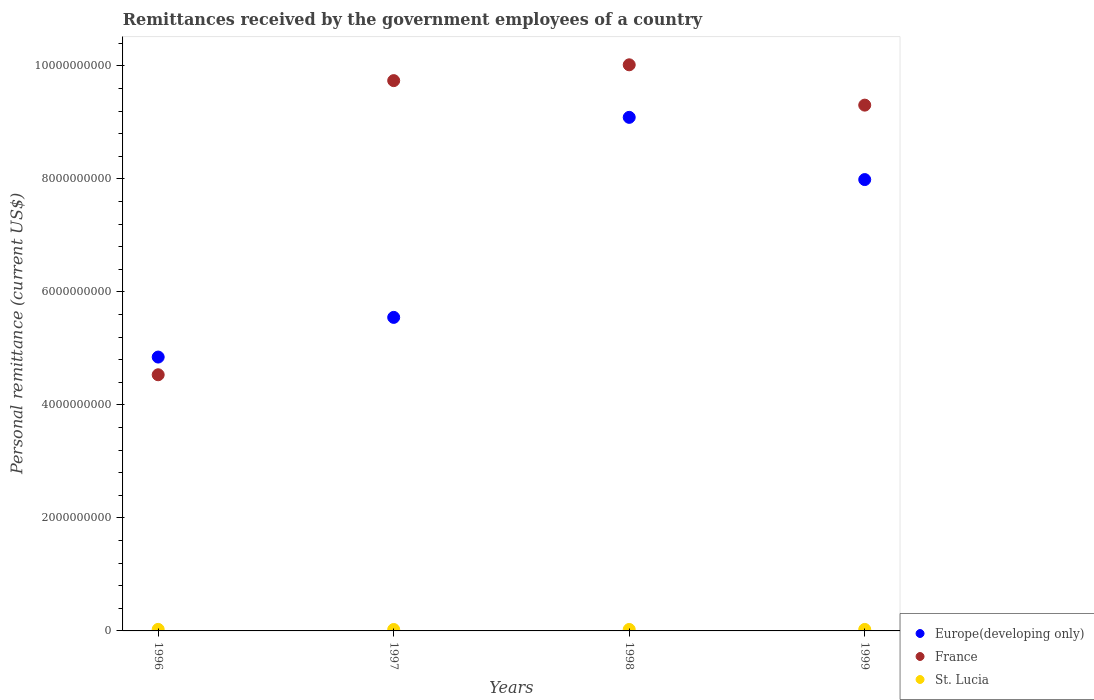What is the remittances received by the government employees in France in 1999?
Keep it short and to the point. 9.31e+09. Across all years, what is the maximum remittances received by the government employees in St. Lucia?
Keep it short and to the point. 2.74e+07. Across all years, what is the minimum remittances received by the government employees in St. Lucia?
Ensure brevity in your answer.  2.52e+07. In which year was the remittances received by the government employees in France minimum?
Ensure brevity in your answer.  1996. What is the total remittances received by the government employees in France in the graph?
Offer a terse response. 3.36e+1. What is the difference between the remittances received by the government employees in Europe(developing only) in 1998 and that in 1999?
Ensure brevity in your answer.  1.10e+09. What is the difference between the remittances received by the government employees in St. Lucia in 1997 and the remittances received by the government employees in Europe(developing only) in 1999?
Offer a very short reply. -7.96e+09. What is the average remittances received by the government employees in St. Lucia per year?
Ensure brevity in your answer.  2.63e+07. In the year 1996, what is the difference between the remittances received by the government employees in St. Lucia and remittances received by the government employees in France?
Ensure brevity in your answer.  -4.51e+09. What is the ratio of the remittances received by the government employees in Europe(developing only) in 1996 to that in 1999?
Your answer should be compact. 0.61. Is the remittances received by the government employees in Europe(developing only) in 1997 less than that in 1998?
Your response must be concise. Yes. Is the difference between the remittances received by the government employees in St. Lucia in 1997 and 1998 greater than the difference between the remittances received by the government employees in France in 1997 and 1998?
Offer a very short reply. Yes. What is the difference between the highest and the second highest remittances received by the government employees in Europe(developing only)?
Provide a succinct answer. 1.10e+09. What is the difference between the highest and the lowest remittances received by the government employees in St. Lucia?
Your response must be concise. 2.17e+06. Is it the case that in every year, the sum of the remittances received by the government employees in Europe(developing only) and remittances received by the government employees in France  is greater than the remittances received by the government employees in St. Lucia?
Ensure brevity in your answer.  Yes. Is the remittances received by the government employees in France strictly greater than the remittances received by the government employees in St. Lucia over the years?
Ensure brevity in your answer.  Yes. Is the remittances received by the government employees in St. Lucia strictly less than the remittances received by the government employees in France over the years?
Your answer should be very brief. Yes. How many dotlines are there?
Your answer should be very brief. 3. How many years are there in the graph?
Provide a succinct answer. 4. What is the difference between two consecutive major ticks on the Y-axis?
Keep it short and to the point. 2.00e+09. Does the graph contain any zero values?
Provide a succinct answer. No. Where does the legend appear in the graph?
Offer a very short reply. Bottom right. How many legend labels are there?
Give a very brief answer. 3. What is the title of the graph?
Give a very brief answer. Remittances received by the government employees of a country. What is the label or title of the Y-axis?
Provide a succinct answer. Personal remittance (current US$). What is the Personal remittance (current US$) in Europe(developing only) in 1996?
Keep it short and to the point. 4.85e+09. What is the Personal remittance (current US$) of France in 1996?
Give a very brief answer. 4.53e+09. What is the Personal remittance (current US$) of St. Lucia in 1996?
Offer a very short reply. 2.74e+07. What is the Personal remittance (current US$) in Europe(developing only) in 1997?
Provide a short and direct response. 5.55e+09. What is the Personal remittance (current US$) of France in 1997?
Keep it short and to the point. 9.74e+09. What is the Personal remittance (current US$) in St. Lucia in 1997?
Keep it short and to the point. 2.52e+07. What is the Personal remittance (current US$) in Europe(developing only) in 1998?
Provide a short and direct response. 9.09e+09. What is the Personal remittance (current US$) in France in 1998?
Your answer should be very brief. 1.00e+1. What is the Personal remittance (current US$) of St. Lucia in 1998?
Give a very brief answer. 2.59e+07. What is the Personal remittance (current US$) of Europe(developing only) in 1999?
Keep it short and to the point. 7.99e+09. What is the Personal remittance (current US$) of France in 1999?
Your response must be concise. 9.31e+09. What is the Personal remittance (current US$) in St. Lucia in 1999?
Offer a terse response. 2.65e+07. Across all years, what is the maximum Personal remittance (current US$) of Europe(developing only)?
Offer a very short reply. 9.09e+09. Across all years, what is the maximum Personal remittance (current US$) of France?
Your answer should be compact. 1.00e+1. Across all years, what is the maximum Personal remittance (current US$) of St. Lucia?
Offer a terse response. 2.74e+07. Across all years, what is the minimum Personal remittance (current US$) in Europe(developing only)?
Your answer should be very brief. 4.85e+09. Across all years, what is the minimum Personal remittance (current US$) of France?
Provide a short and direct response. 4.53e+09. Across all years, what is the minimum Personal remittance (current US$) in St. Lucia?
Provide a short and direct response. 2.52e+07. What is the total Personal remittance (current US$) in Europe(developing only) in the graph?
Your response must be concise. 2.75e+1. What is the total Personal remittance (current US$) in France in the graph?
Offer a terse response. 3.36e+1. What is the total Personal remittance (current US$) of St. Lucia in the graph?
Provide a succinct answer. 1.05e+08. What is the difference between the Personal remittance (current US$) in Europe(developing only) in 1996 and that in 1997?
Provide a succinct answer. -7.02e+08. What is the difference between the Personal remittance (current US$) of France in 1996 and that in 1997?
Your answer should be very brief. -5.21e+09. What is the difference between the Personal remittance (current US$) in St. Lucia in 1996 and that in 1997?
Make the answer very short. 2.17e+06. What is the difference between the Personal remittance (current US$) of Europe(developing only) in 1996 and that in 1998?
Provide a short and direct response. -4.24e+09. What is the difference between the Personal remittance (current US$) of France in 1996 and that in 1998?
Give a very brief answer. -5.49e+09. What is the difference between the Personal remittance (current US$) of St. Lucia in 1996 and that in 1998?
Provide a short and direct response. 1.47e+06. What is the difference between the Personal remittance (current US$) in Europe(developing only) in 1996 and that in 1999?
Provide a short and direct response. -3.14e+09. What is the difference between the Personal remittance (current US$) of France in 1996 and that in 1999?
Offer a terse response. -4.77e+09. What is the difference between the Personal remittance (current US$) in St. Lucia in 1996 and that in 1999?
Ensure brevity in your answer.  8.48e+05. What is the difference between the Personal remittance (current US$) in Europe(developing only) in 1997 and that in 1998?
Your response must be concise. -3.54e+09. What is the difference between the Personal remittance (current US$) in France in 1997 and that in 1998?
Keep it short and to the point. -2.80e+08. What is the difference between the Personal remittance (current US$) in St. Lucia in 1997 and that in 1998?
Keep it short and to the point. -7.00e+05. What is the difference between the Personal remittance (current US$) of Europe(developing only) in 1997 and that in 1999?
Make the answer very short. -2.44e+09. What is the difference between the Personal remittance (current US$) in France in 1997 and that in 1999?
Your response must be concise. 4.34e+08. What is the difference between the Personal remittance (current US$) of St. Lucia in 1997 and that in 1999?
Provide a short and direct response. -1.32e+06. What is the difference between the Personal remittance (current US$) of Europe(developing only) in 1998 and that in 1999?
Offer a very short reply. 1.10e+09. What is the difference between the Personal remittance (current US$) in France in 1998 and that in 1999?
Make the answer very short. 7.14e+08. What is the difference between the Personal remittance (current US$) in St. Lucia in 1998 and that in 1999?
Give a very brief answer. -6.22e+05. What is the difference between the Personal remittance (current US$) in Europe(developing only) in 1996 and the Personal remittance (current US$) in France in 1997?
Offer a terse response. -4.89e+09. What is the difference between the Personal remittance (current US$) of Europe(developing only) in 1996 and the Personal remittance (current US$) of St. Lucia in 1997?
Offer a terse response. 4.82e+09. What is the difference between the Personal remittance (current US$) in France in 1996 and the Personal remittance (current US$) in St. Lucia in 1997?
Offer a very short reply. 4.51e+09. What is the difference between the Personal remittance (current US$) in Europe(developing only) in 1996 and the Personal remittance (current US$) in France in 1998?
Your response must be concise. -5.17e+09. What is the difference between the Personal remittance (current US$) of Europe(developing only) in 1996 and the Personal remittance (current US$) of St. Lucia in 1998?
Your answer should be very brief. 4.82e+09. What is the difference between the Personal remittance (current US$) of France in 1996 and the Personal remittance (current US$) of St. Lucia in 1998?
Keep it short and to the point. 4.51e+09. What is the difference between the Personal remittance (current US$) of Europe(developing only) in 1996 and the Personal remittance (current US$) of France in 1999?
Give a very brief answer. -4.46e+09. What is the difference between the Personal remittance (current US$) of Europe(developing only) in 1996 and the Personal remittance (current US$) of St. Lucia in 1999?
Your response must be concise. 4.82e+09. What is the difference between the Personal remittance (current US$) in France in 1996 and the Personal remittance (current US$) in St. Lucia in 1999?
Your answer should be very brief. 4.51e+09. What is the difference between the Personal remittance (current US$) in Europe(developing only) in 1997 and the Personal remittance (current US$) in France in 1998?
Your response must be concise. -4.47e+09. What is the difference between the Personal remittance (current US$) in Europe(developing only) in 1997 and the Personal remittance (current US$) in St. Lucia in 1998?
Your answer should be very brief. 5.52e+09. What is the difference between the Personal remittance (current US$) in France in 1997 and the Personal remittance (current US$) in St. Lucia in 1998?
Ensure brevity in your answer.  9.72e+09. What is the difference between the Personal remittance (current US$) of Europe(developing only) in 1997 and the Personal remittance (current US$) of France in 1999?
Provide a short and direct response. -3.76e+09. What is the difference between the Personal remittance (current US$) in Europe(developing only) in 1997 and the Personal remittance (current US$) in St. Lucia in 1999?
Keep it short and to the point. 5.52e+09. What is the difference between the Personal remittance (current US$) of France in 1997 and the Personal remittance (current US$) of St. Lucia in 1999?
Offer a terse response. 9.71e+09. What is the difference between the Personal remittance (current US$) of Europe(developing only) in 1998 and the Personal remittance (current US$) of France in 1999?
Ensure brevity in your answer.  -2.16e+08. What is the difference between the Personal remittance (current US$) of Europe(developing only) in 1998 and the Personal remittance (current US$) of St. Lucia in 1999?
Give a very brief answer. 9.06e+09. What is the difference between the Personal remittance (current US$) in France in 1998 and the Personal remittance (current US$) in St. Lucia in 1999?
Offer a terse response. 9.99e+09. What is the average Personal remittance (current US$) of Europe(developing only) per year?
Make the answer very short. 6.87e+09. What is the average Personal remittance (current US$) in France per year?
Offer a terse response. 8.40e+09. What is the average Personal remittance (current US$) of St. Lucia per year?
Make the answer very short. 2.63e+07. In the year 1996, what is the difference between the Personal remittance (current US$) in Europe(developing only) and Personal remittance (current US$) in France?
Ensure brevity in your answer.  3.13e+08. In the year 1996, what is the difference between the Personal remittance (current US$) of Europe(developing only) and Personal remittance (current US$) of St. Lucia?
Offer a very short reply. 4.82e+09. In the year 1996, what is the difference between the Personal remittance (current US$) in France and Personal remittance (current US$) in St. Lucia?
Your answer should be very brief. 4.51e+09. In the year 1997, what is the difference between the Personal remittance (current US$) of Europe(developing only) and Personal remittance (current US$) of France?
Your response must be concise. -4.19e+09. In the year 1997, what is the difference between the Personal remittance (current US$) in Europe(developing only) and Personal remittance (current US$) in St. Lucia?
Give a very brief answer. 5.52e+09. In the year 1997, what is the difference between the Personal remittance (current US$) of France and Personal remittance (current US$) of St. Lucia?
Provide a succinct answer. 9.72e+09. In the year 1998, what is the difference between the Personal remittance (current US$) of Europe(developing only) and Personal remittance (current US$) of France?
Give a very brief answer. -9.30e+08. In the year 1998, what is the difference between the Personal remittance (current US$) in Europe(developing only) and Personal remittance (current US$) in St. Lucia?
Ensure brevity in your answer.  9.06e+09. In the year 1998, what is the difference between the Personal remittance (current US$) in France and Personal remittance (current US$) in St. Lucia?
Your answer should be very brief. 1.00e+1. In the year 1999, what is the difference between the Personal remittance (current US$) of Europe(developing only) and Personal remittance (current US$) of France?
Your response must be concise. -1.32e+09. In the year 1999, what is the difference between the Personal remittance (current US$) of Europe(developing only) and Personal remittance (current US$) of St. Lucia?
Keep it short and to the point. 7.96e+09. In the year 1999, what is the difference between the Personal remittance (current US$) of France and Personal remittance (current US$) of St. Lucia?
Make the answer very short. 9.28e+09. What is the ratio of the Personal remittance (current US$) in Europe(developing only) in 1996 to that in 1997?
Provide a succinct answer. 0.87. What is the ratio of the Personal remittance (current US$) in France in 1996 to that in 1997?
Offer a terse response. 0.47. What is the ratio of the Personal remittance (current US$) of St. Lucia in 1996 to that in 1997?
Provide a short and direct response. 1.09. What is the ratio of the Personal remittance (current US$) in Europe(developing only) in 1996 to that in 1998?
Give a very brief answer. 0.53. What is the ratio of the Personal remittance (current US$) of France in 1996 to that in 1998?
Your answer should be compact. 0.45. What is the ratio of the Personal remittance (current US$) in St. Lucia in 1996 to that in 1998?
Give a very brief answer. 1.06. What is the ratio of the Personal remittance (current US$) of Europe(developing only) in 1996 to that in 1999?
Offer a terse response. 0.61. What is the ratio of the Personal remittance (current US$) of France in 1996 to that in 1999?
Give a very brief answer. 0.49. What is the ratio of the Personal remittance (current US$) in St. Lucia in 1996 to that in 1999?
Your response must be concise. 1.03. What is the ratio of the Personal remittance (current US$) of Europe(developing only) in 1997 to that in 1998?
Ensure brevity in your answer.  0.61. What is the ratio of the Personal remittance (current US$) of France in 1997 to that in 1998?
Your answer should be compact. 0.97. What is the ratio of the Personal remittance (current US$) in St. Lucia in 1997 to that in 1998?
Provide a short and direct response. 0.97. What is the ratio of the Personal remittance (current US$) of Europe(developing only) in 1997 to that in 1999?
Your answer should be very brief. 0.69. What is the ratio of the Personal remittance (current US$) of France in 1997 to that in 1999?
Your answer should be compact. 1.05. What is the ratio of the Personal remittance (current US$) of St. Lucia in 1997 to that in 1999?
Make the answer very short. 0.95. What is the ratio of the Personal remittance (current US$) in Europe(developing only) in 1998 to that in 1999?
Ensure brevity in your answer.  1.14. What is the ratio of the Personal remittance (current US$) of France in 1998 to that in 1999?
Your response must be concise. 1.08. What is the ratio of the Personal remittance (current US$) of St. Lucia in 1998 to that in 1999?
Your response must be concise. 0.98. What is the difference between the highest and the second highest Personal remittance (current US$) of Europe(developing only)?
Offer a terse response. 1.10e+09. What is the difference between the highest and the second highest Personal remittance (current US$) in France?
Ensure brevity in your answer.  2.80e+08. What is the difference between the highest and the second highest Personal remittance (current US$) in St. Lucia?
Offer a very short reply. 8.48e+05. What is the difference between the highest and the lowest Personal remittance (current US$) of Europe(developing only)?
Provide a short and direct response. 4.24e+09. What is the difference between the highest and the lowest Personal remittance (current US$) of France?
Keep it short and to the point. 5.49e+09. What is the difference between the highest and the lowest Personal remittance (current US$) in St. Lucia?
Provide a succinct answer. 2.17e+06. 